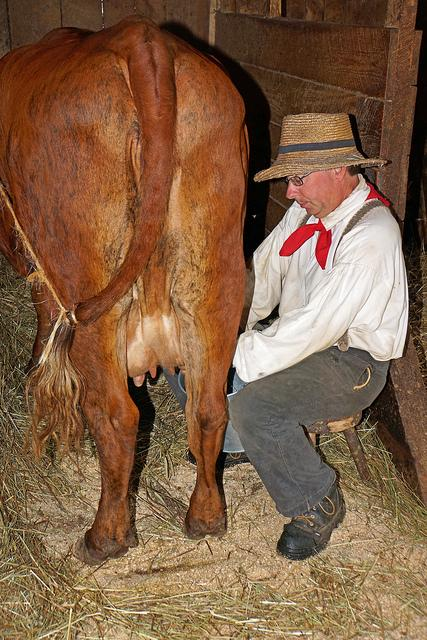What activity is this man involved in? milking 